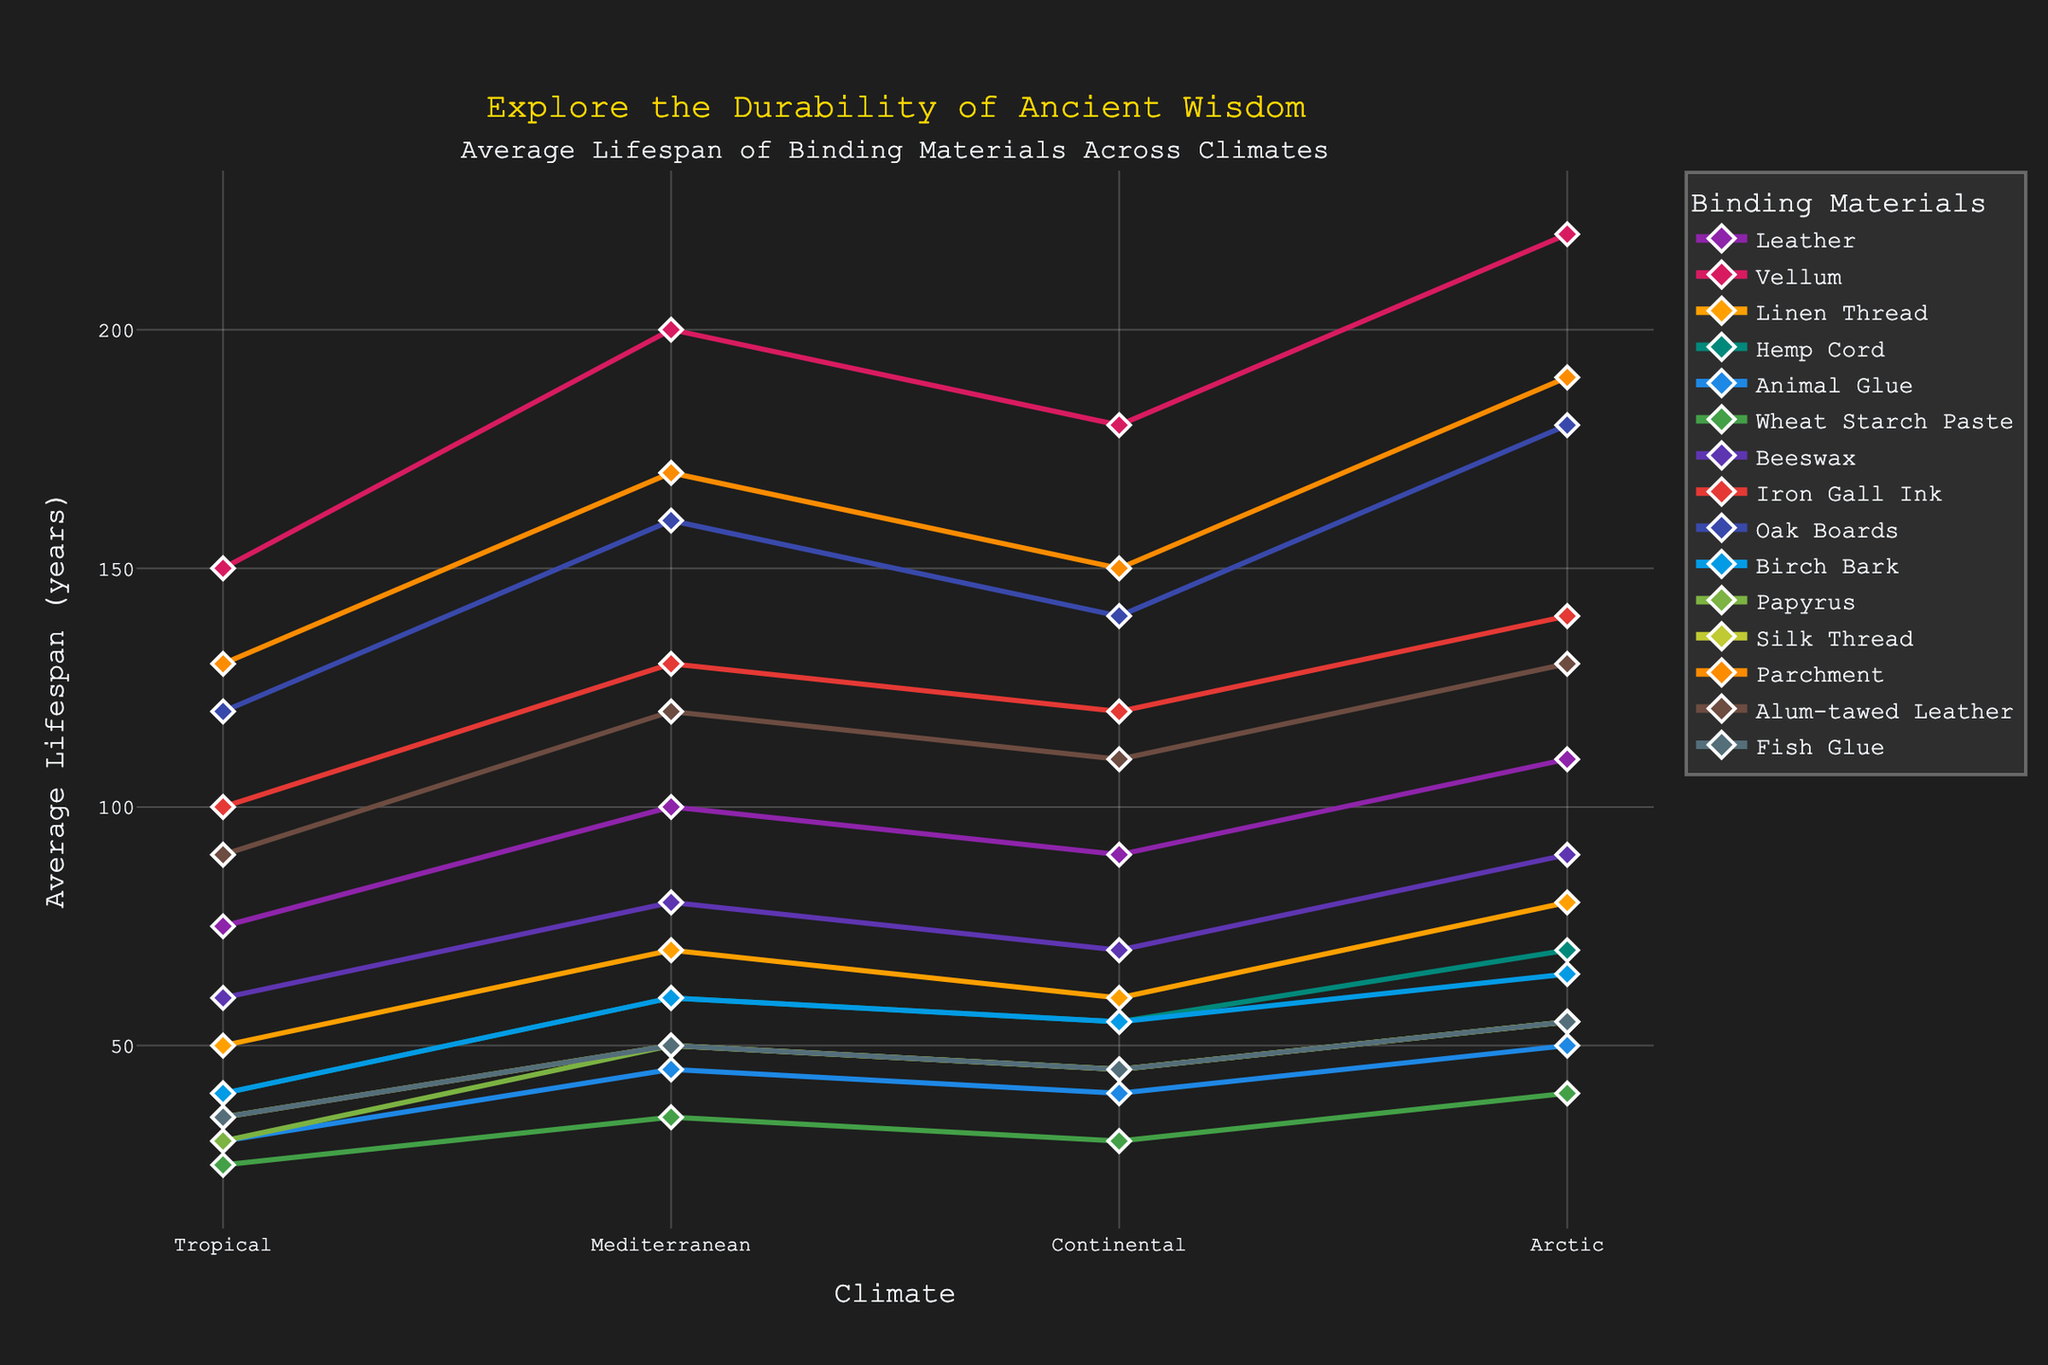Which binding material has the longest lifespan in an Arctic climate? Observing the chart, the material with the highest point in the Arctic climate line is Vellum.
Answer: Vellum How much longer is the average lifespan of Parchment in a Continental climate compared to Iron Gall Ink in a Tropical climate? In the figure, Parchment in the Continental climate has a lifespan of 150 years, and Iron Gall Ink in the Tropical climate has a lifespan of 100 years. The difference is 150 - 100 = 50 years.
Answer: 50 years Which material shows the least variation in lifespan across the different climates? By examining the spread of the lifespans across climates for each material, Iron Gall Ink has the least variation as its values range from 100 to 140 years.
Answer: Iron Gall Ink Is the lifespan of Beeswax in a Mediterranean climate greater than Alum-tawed Leather in a Tropical climate? Looking at the chart, Beeswax has a lifespan of 80 years in a Mediterranean climate, while Alum-tawed Leather has a lifespan of 90 years in a Tropical climate. 80 is less than 90.
Answer: No Which two materials have the closest average lifespan in a Continental climate? By analyzing the chart, Birch Bark and Hemp Cord both have close lifespans in a Continental climate: Birch Bark (55 years) and Hemp Cord (55 years).
Answer: Birch Bark and Hemp Cord What is the average lifespan of Wheat Starch Paste across all climates? From the chart, Wheat Starch Paste has lifespans of 25, 35, 30, and 40 years in Tropical, Mediterranean, Continental, and Arctic climates respectively. The sum is 25 + 35 + 30 + 40 = 130. The average is 130 / 4 = 32.5 years.
Answer: 32.5 years Compare the lifespan of Oak Boards and Silk Thread in a Mediterranean climate. Which one has a longer lifespan and by how much? In that climate, Oak Boards have a lifespan of 160 years and Silk Thread has 50 years. The difference is 160 - 50 = 110 years.
Answer: Oak Boards by 110 years What is the total lifespan of all binding materials in a Tropical climate? Summing up all the lifespans for the Tropical climate from the chart: 75 + 150 + 50 + 40 + 30 + 25 + 60 + 100 + 120 + 40 + 30 + 35 + 130 + 90 + 35 = 1010 years.
Answer: 1010 years Is there a material whose lifespan increases consistently across all climates from Tropical to Arctic? If so, which one? By examining the lines for each material, Vellum’s lifespan consistently increases from Tropical (150), Mediterranean (200), Continental (180), to Arctic (220).
Answer: Vellum How does the lifespan of Linen Thread in a Continental climate compare to that of Animal Glue in an Arctic climate? The chart shows that Linen Thread has a lifespan of 60 years in a Continental climate while Animal Glue has 50 years in an Arctic climate. 60 is greater than 50.
Answer: Linen Thread, longer by 10 years 